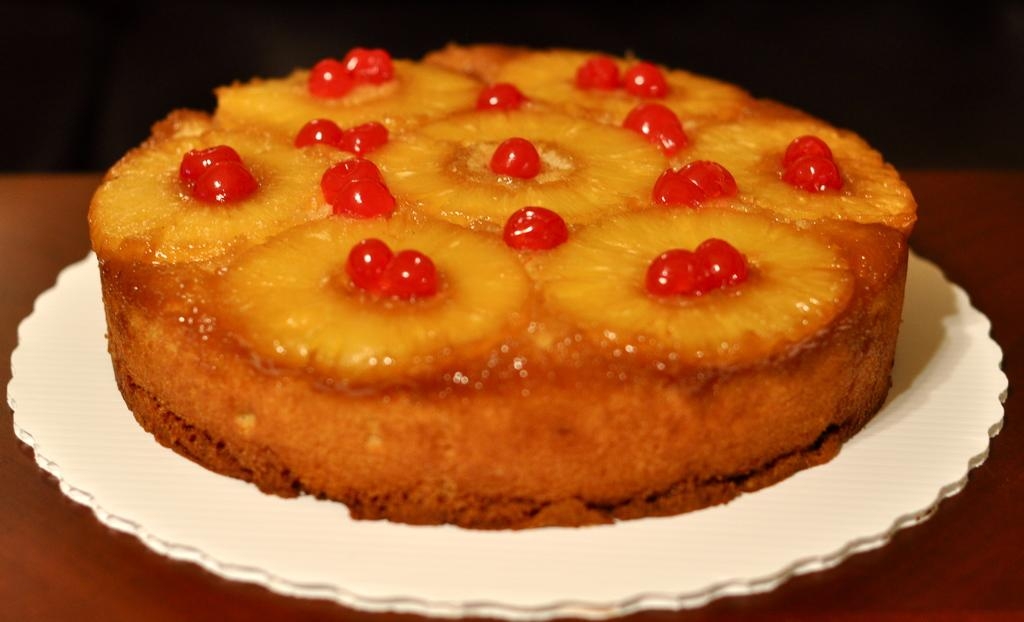What is the main subject of the image? The main subject of the image is a baked cake. What type of fruit can be seen on the cake? There are pineapple slices on the cake. What other type of fruit is present on the cake? There are cherries on the cake. What idea does the cake represent in the image? The image does not convey any specific ideas or concepts; it simply shows a cake with pineapple slices and cherries. Does the cake in the image cause any feelings of regret? The image does not convey any feelings or emotions, including regret; it simply shows a cake with pineapple slices and cherries. 